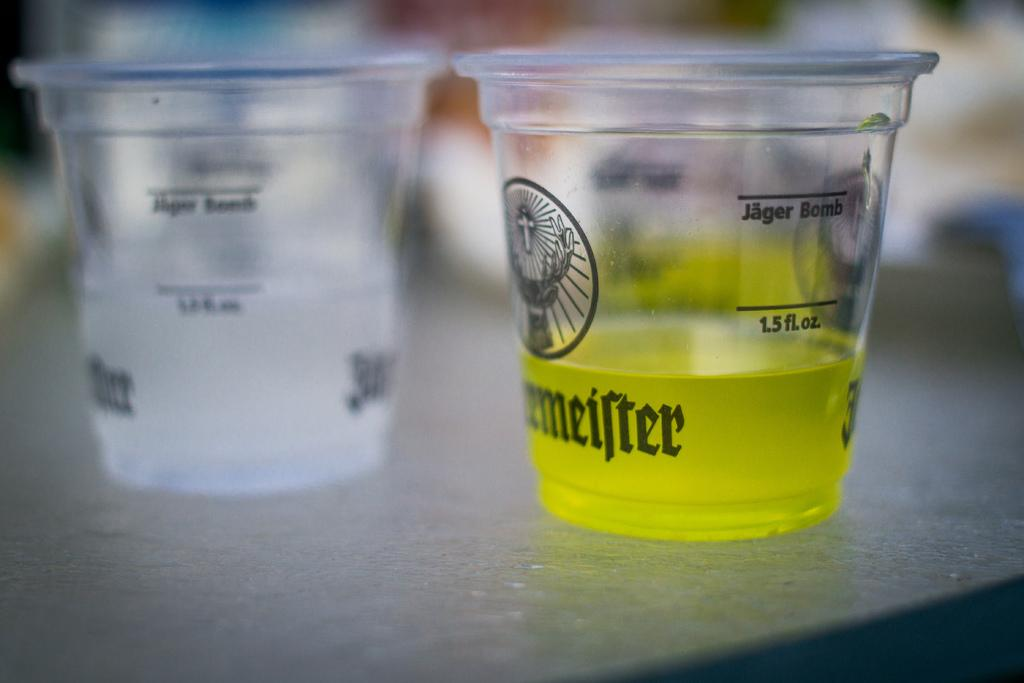<image>
Write a terse but informative summary of the picture. Two cups on a table both say Jagermeister. 